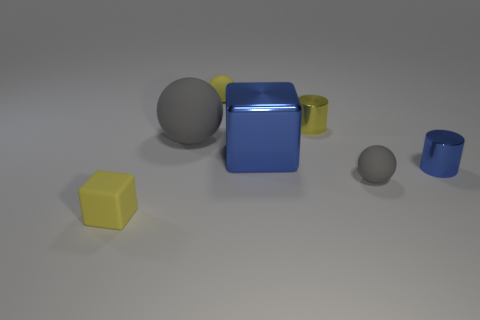Add 2 large blue metallic cubes. How many objects exist? 9 Subtract all spheres. How many objects are left? 4 Add 3 small yellow cylinders. How many small yellow cylinders are left? 4 Add 4 blue shiny cylinders. How many blue shiny cylinders exist? 5 Subtract 1 yellow balls. How many objects are left? 6 Subtract all tiny yellow rubber objects. Subtract all tiny yellow rubber objects. How many objects are left? 3 